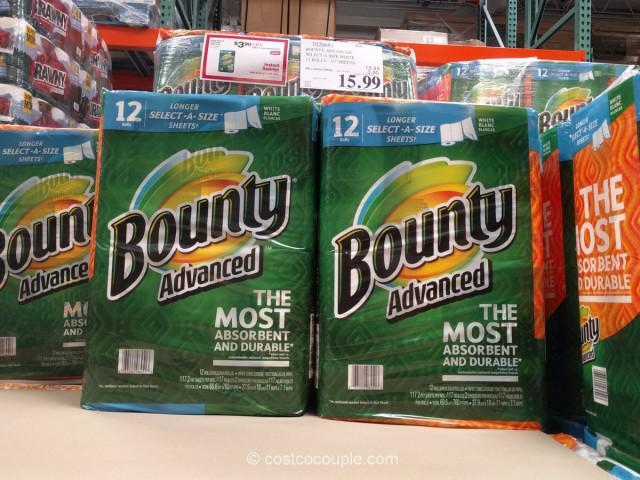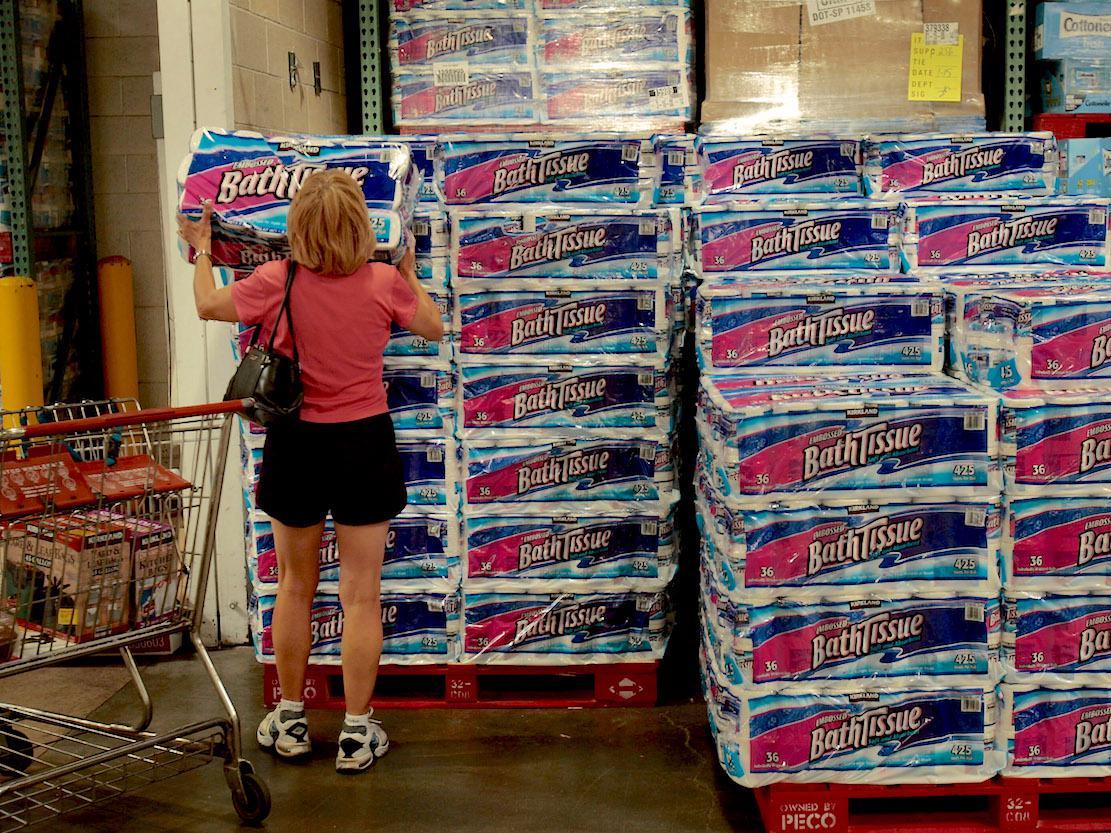The first image is the image on the left, the second image is the image on the right. Assess this claim about the two images: "at least one image has the price tags on the shelf". Correct or not? Answer yes or no. No. 